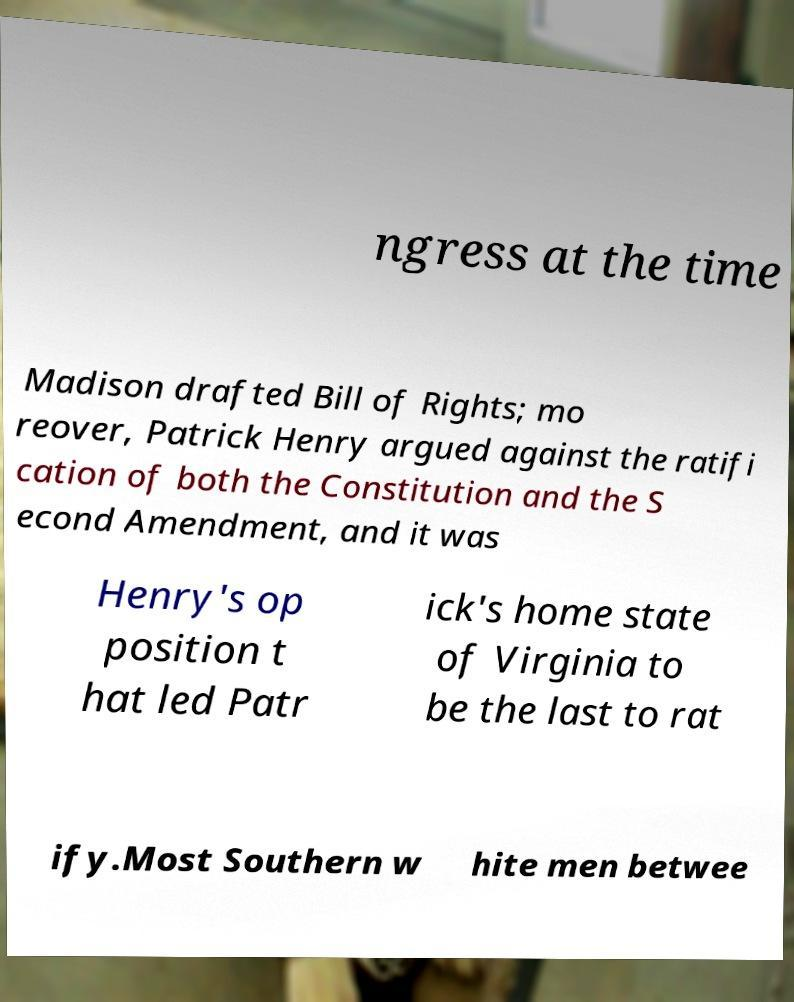Please read and relay the text visible in this image. What does it say? ngress at the time Madison drafted Bill of Rights; mo reover, Patrick Henry argued against the ratifi cation of both the Constitution and the S econd Amendment, and it was Henry's op position t hat led Patr ick's home state of Virginia to be the last to rat ify.Most Southern w hite men betwee 